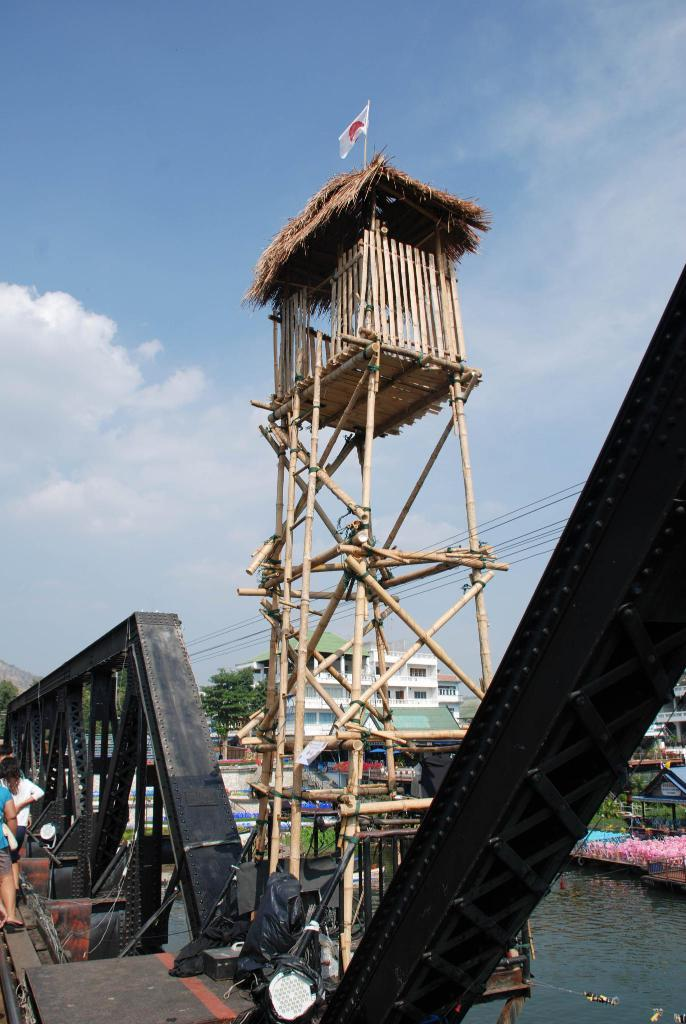How many people can be seen in the image? There are people in the image. What objects are made of wood in the image? There are wooden sticks in the image. What type of structure is present in the image? There is a hut in the image. What is attached to the hut in the image? There is a flag in the image. What type of illumination is present in the image? There are lights in the image. What type of residential structures are visible in the image? There are houses in the image. What architectural feature can be seen in the image? There is a railing in the image. What type of natural environment is visible in the image? There is water visible in the image. What type of flora is present in the image? There are flowers in the image. What type of vegetation is present in the image? There are trees in the image. What part of the natural environment is visible in the image? The sky is visible in the image. What type of liquid is visible in the image? The water is visible in the image. Where is the desk located in the image? There is no desk present in the image. How many pigs can be seen in the image? There are no pigs present in the image. 